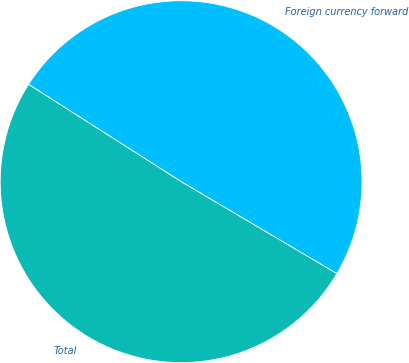Convert chart to OTSL. <chart><loc_0><loc_0><loc_500><loc_500><pie_chart><fcel>Foreign currency forward<fcel>Total<nl><fcel>49.46%<fcel>50.54%<nl></chart> 